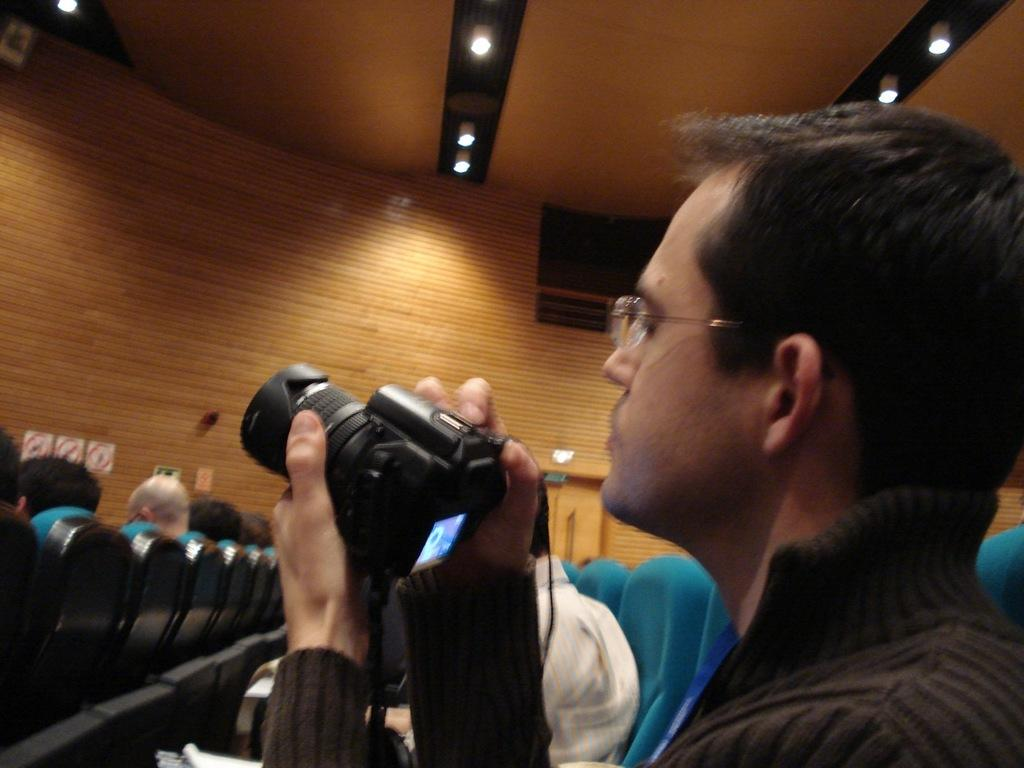Who is present in the image? There is a man in the image. What is the man doing in the image? The man is sitting on a chair in the image. What is the man holding in his hand? The man is holding a camera in his hand. Are there any other people in the image? Yes, there are people seated in the chairs in the image. What type of stamp can be seen on the man's forehead in the image? There is no stamp visible on the man's forehead in the image. Can you describe the goose that is flying above the people in the image? There is no goose present in the image; it only features a man and other people seated in chairs. 